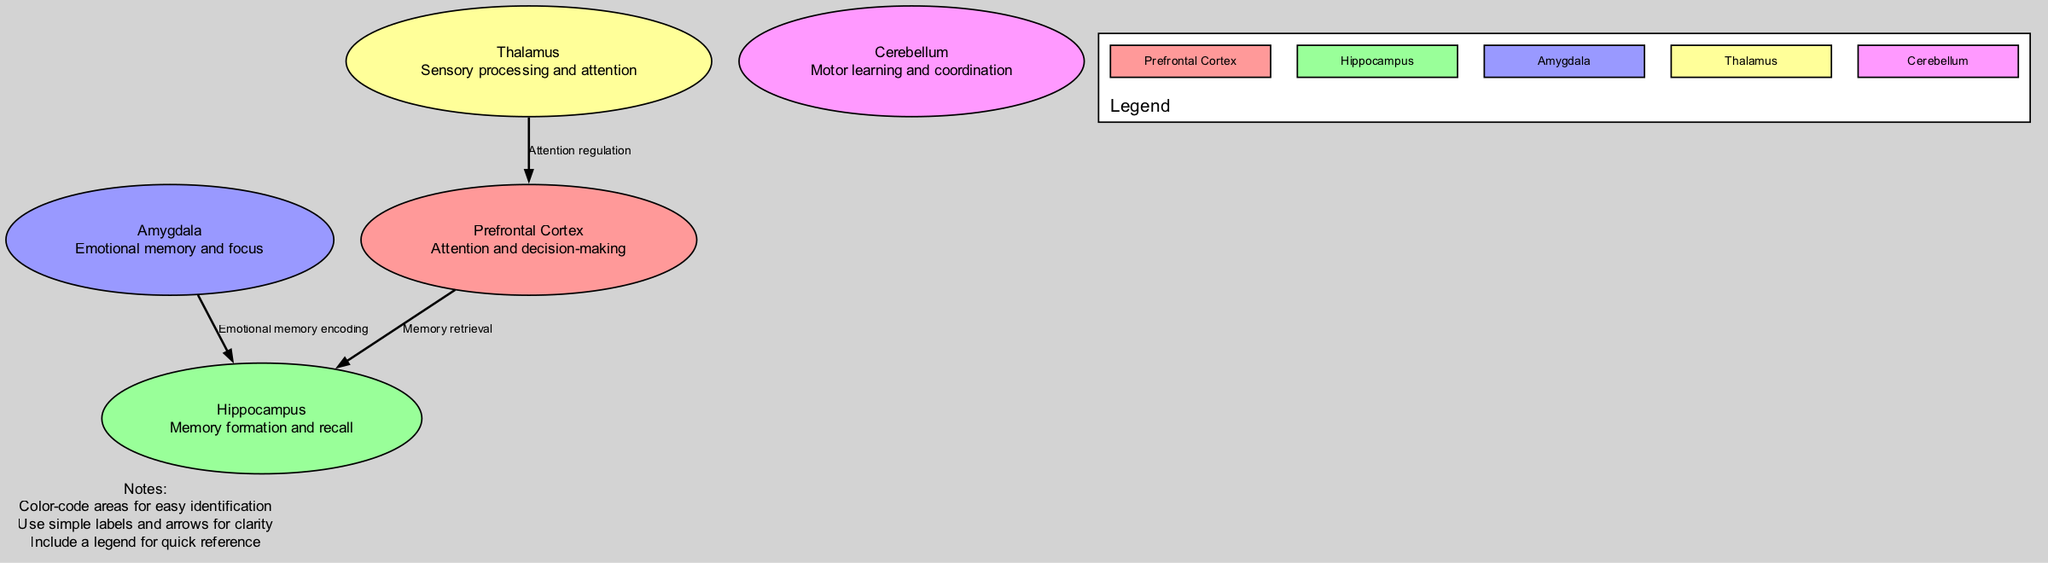What area is responsible for attention and decision-making? The diagram labels the "Prefrontal Cortex" as responsible for attention and decision-making. By looking at the nodes, the description for the "Prefrontal Cortex" clearly states these functions.
Answer: Prefrontal Cortex How many areas are related to memory in the diagram? The areas related to memory include the "Hippocampus" and "Amygdala." Counting these labeled areas gives a total of two memory-related areas in the diagram.
Answer: 2 What is the relationship between the Thalamus and the Prefrontal Cortex? The diagram shows an edge from "Thalamus" to "Prefrontal Cortex" labeled "Attention regulation," indicating that the Thalamus influences attention processes in the Prefrontal Cortex.
Answer: Attention regulation What two areas are connected by an edge labeled "Memory retrieval"? The edge labeled "Memory retrieval" connects the "Prefrontal Cortex" to the "Hippocampus." This describes the flow of information related to recalling memories between these two areas.
Answer: Prefrontal Cortex and Hippocampus Which area encodes emotional memory? The diagram specifies that the "Amygdala" is responsible for emotional memory encoding. The edge leading from the Amygdala to the Hippocampus in the diagram indicates this relationship.
Answer: Amygdala What color represents the Hippocampus in the diagram? The Hippocampus is represented in green according to the color scheme defined in the diagram. Each area has a unique color assigned for easy identification.
Answer: Green Which area is highlighted for sensory processing? The diagram indicates that the "Thalamus" is involved in sensory processing and attention, reflecting the area’s responsibilities as labeled in the description node.
Answer: Thalamus What role does the Cerebellum play according to the diagram? The diagram describes the "Cerebellum" as related to motor learning and coordination. This function is outlined in the description associated with the Cerebellum node.
Answer: Motor learning and coordination How many edges are depicted in the diagram? The diagram shows three edges connecting various areas: two from the Thalamus and Amygdala to the Prefrontal Cortex and Hippocampus, respectively, and one from Prefrontal Cortex to Hippocampus, making a total of three edges.
Answer: 3 